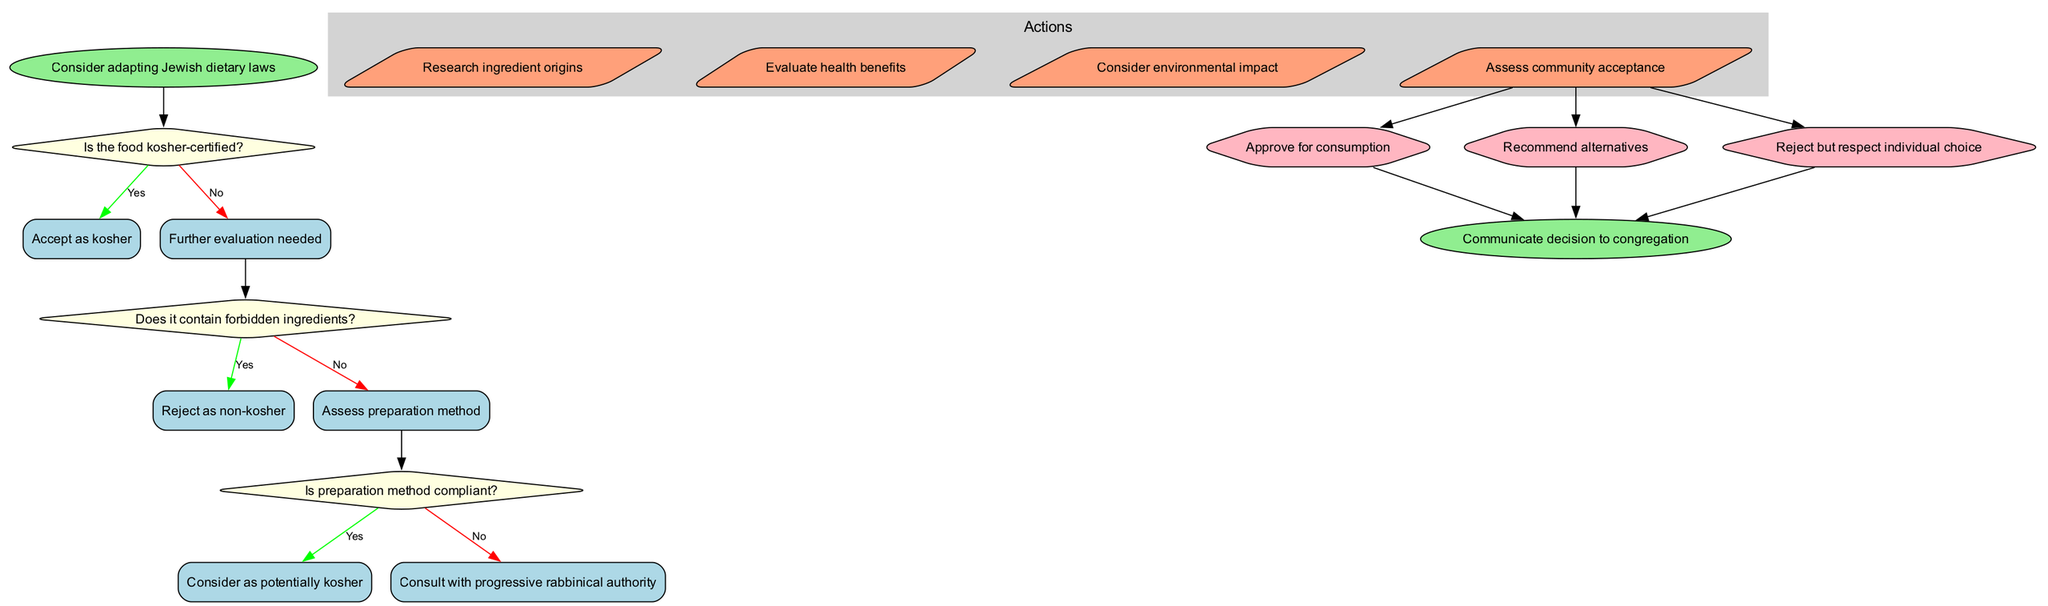What is the start node of the diagram? The diagram begins with the node labeled "Consider adapting Jewish dietary laws." This is the entry point of the flow chart indicating the subject at hand.
Answer: Consider adapting Jewish dietary laws How many decision nodes are present in the diagram? The diagram contains three decision nodes. These are the points where questions about the dietary laws are posed, leading to different subsequent actions or decisions.
Answer: 3 What happens if the food is not kosher-certified? If the food is not kosher-certified, it leads to the action "Further evaluation needed," indicating that additional steps must be taken to assess the food's compliance with dietary laws.
Answer: Further evaluation needed What is the first action after considering the preparation method? After assessing the preparation method, the first action is "Research ingredient origins," which indicates the next step to be taken in the evaluation process.
Answer: Research ingredient origins What are the two possible outcomes after consulting with a progressive rabbinical authority? After consulting with a progressive rabbinical authority, the two possible outcomes are "Approve for consumption" and "Recommend alternatives," indicating different paths based on the consultation's results.
Answer: Approve for consumption, Recommend alternatives If the preparation method is compliant, what is the next question addressed? If the preparation method is compliant, the diagram indicates the action "Consider as potentially kosher," which implies that this is a continuation of the evaluation process without posing a new question directly.
Answer: Consider as potentially kosher What is the final action before communicating the decision to the congregation? Before communicating the decision to the congregation, the final actions stem from the final decision nodes, concluding the process with a determination based on previous evaluations.
Answer: Communicate decision to congregation 